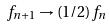Convert formula to latex. <formula><loc_0><loc_0><loc_500><loc_500>f _ { n + 1 } \rightarrow ( 1 / 2 ) f _ { n }</formula> 